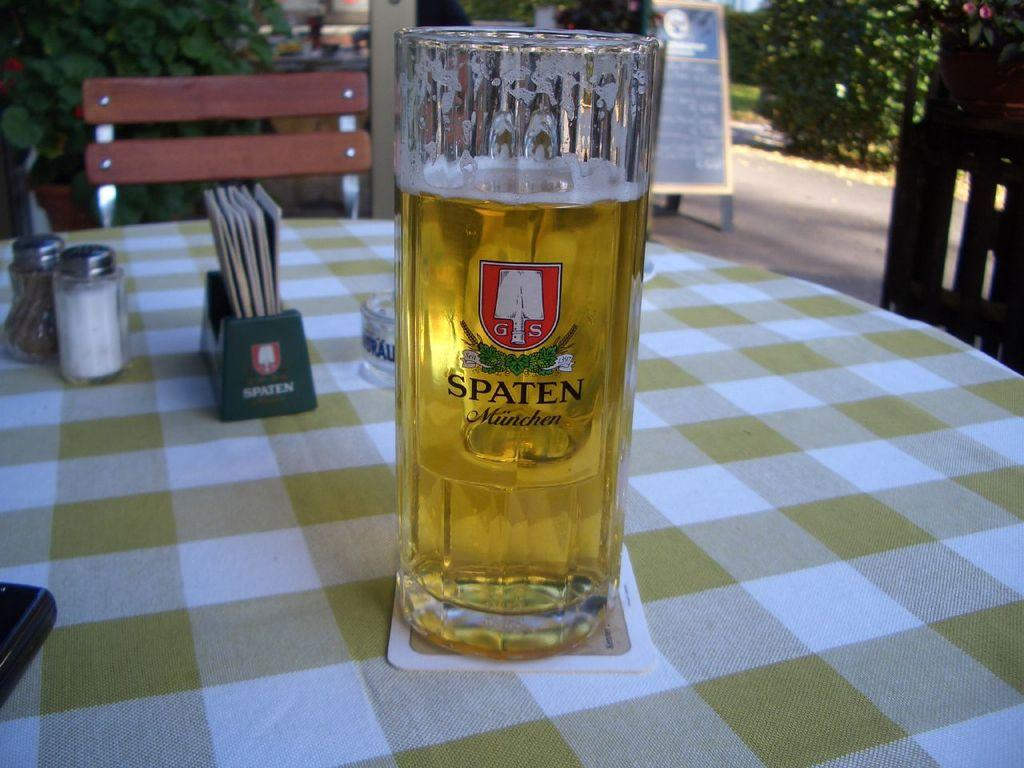<image>
Create a compact narrative representing the image presented. a beer glass has Spaten written on it 